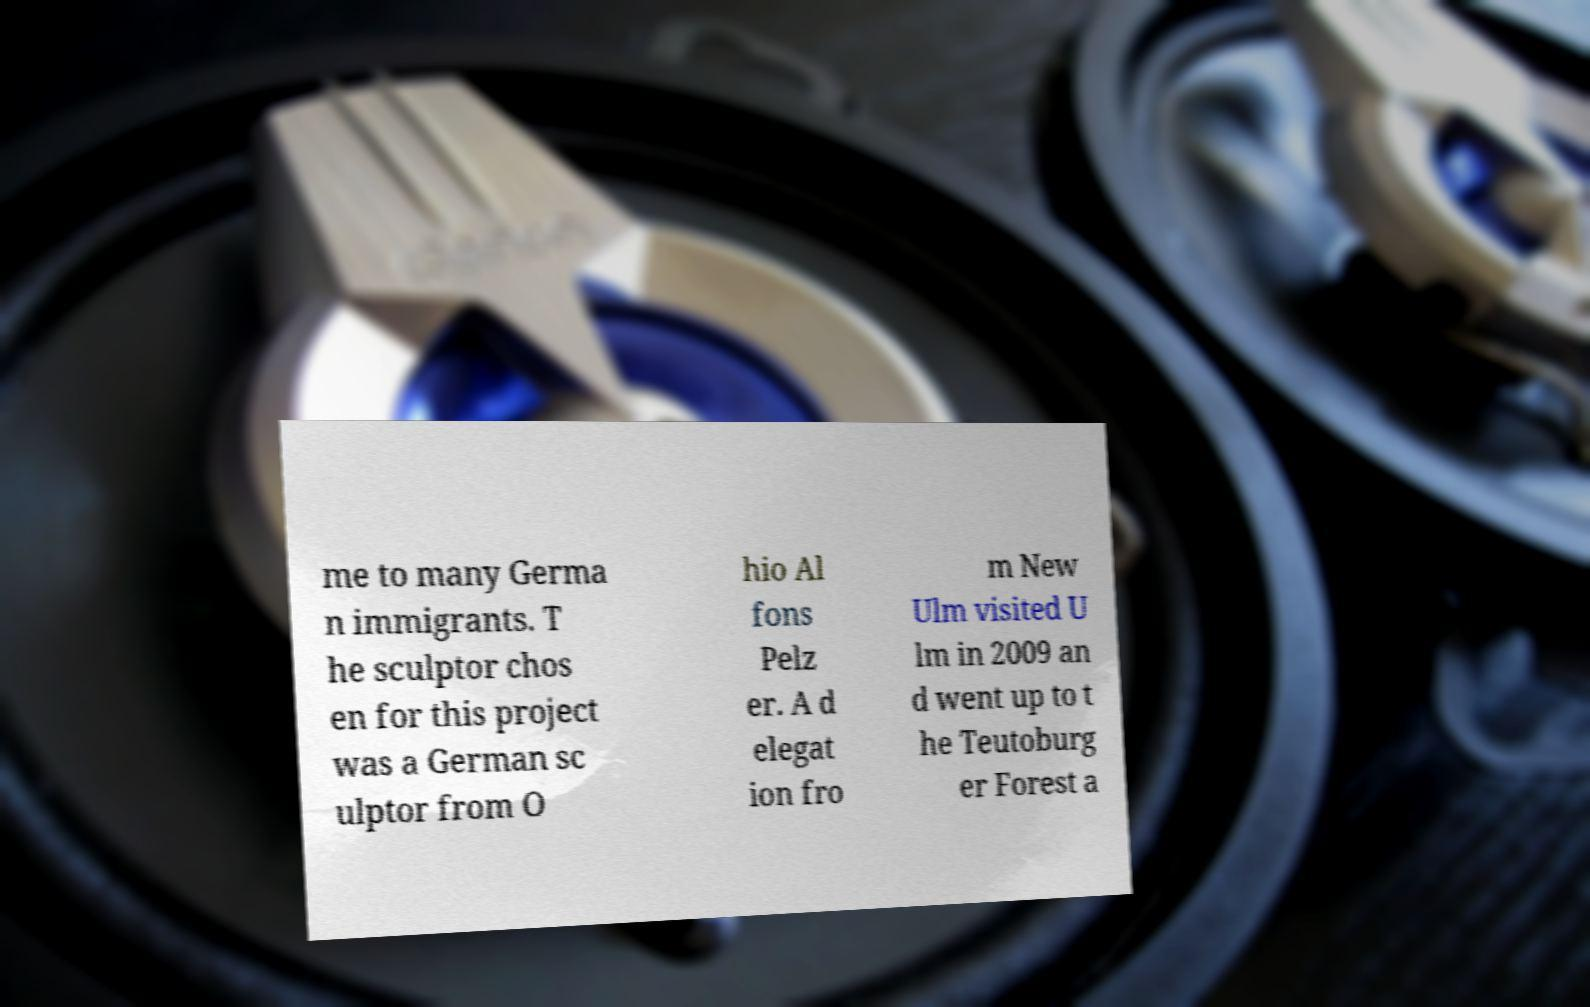I need the written content from this picture converted into text. Can you do that? me to many Germa n immigrants. T he sculptor chos en for this project was a German sc ulptor from O hio Al fons Pelz er. A d elegat ion fro m New Ulm visited U lm in 2009 an d went up to t he Teutoburg er Forest a 